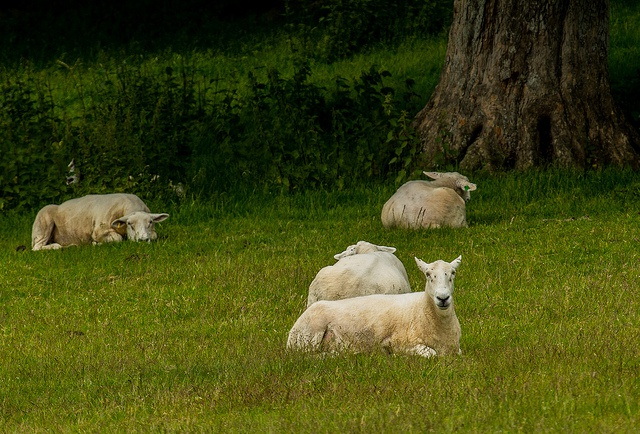Describe the objects in this image and their specific colors. I can see sheep in black, tan, and olive tones, sheep in black, tan, and olive tones, sheep in black and tan tones, and sheep in black, tan, and olive tones in this image. 